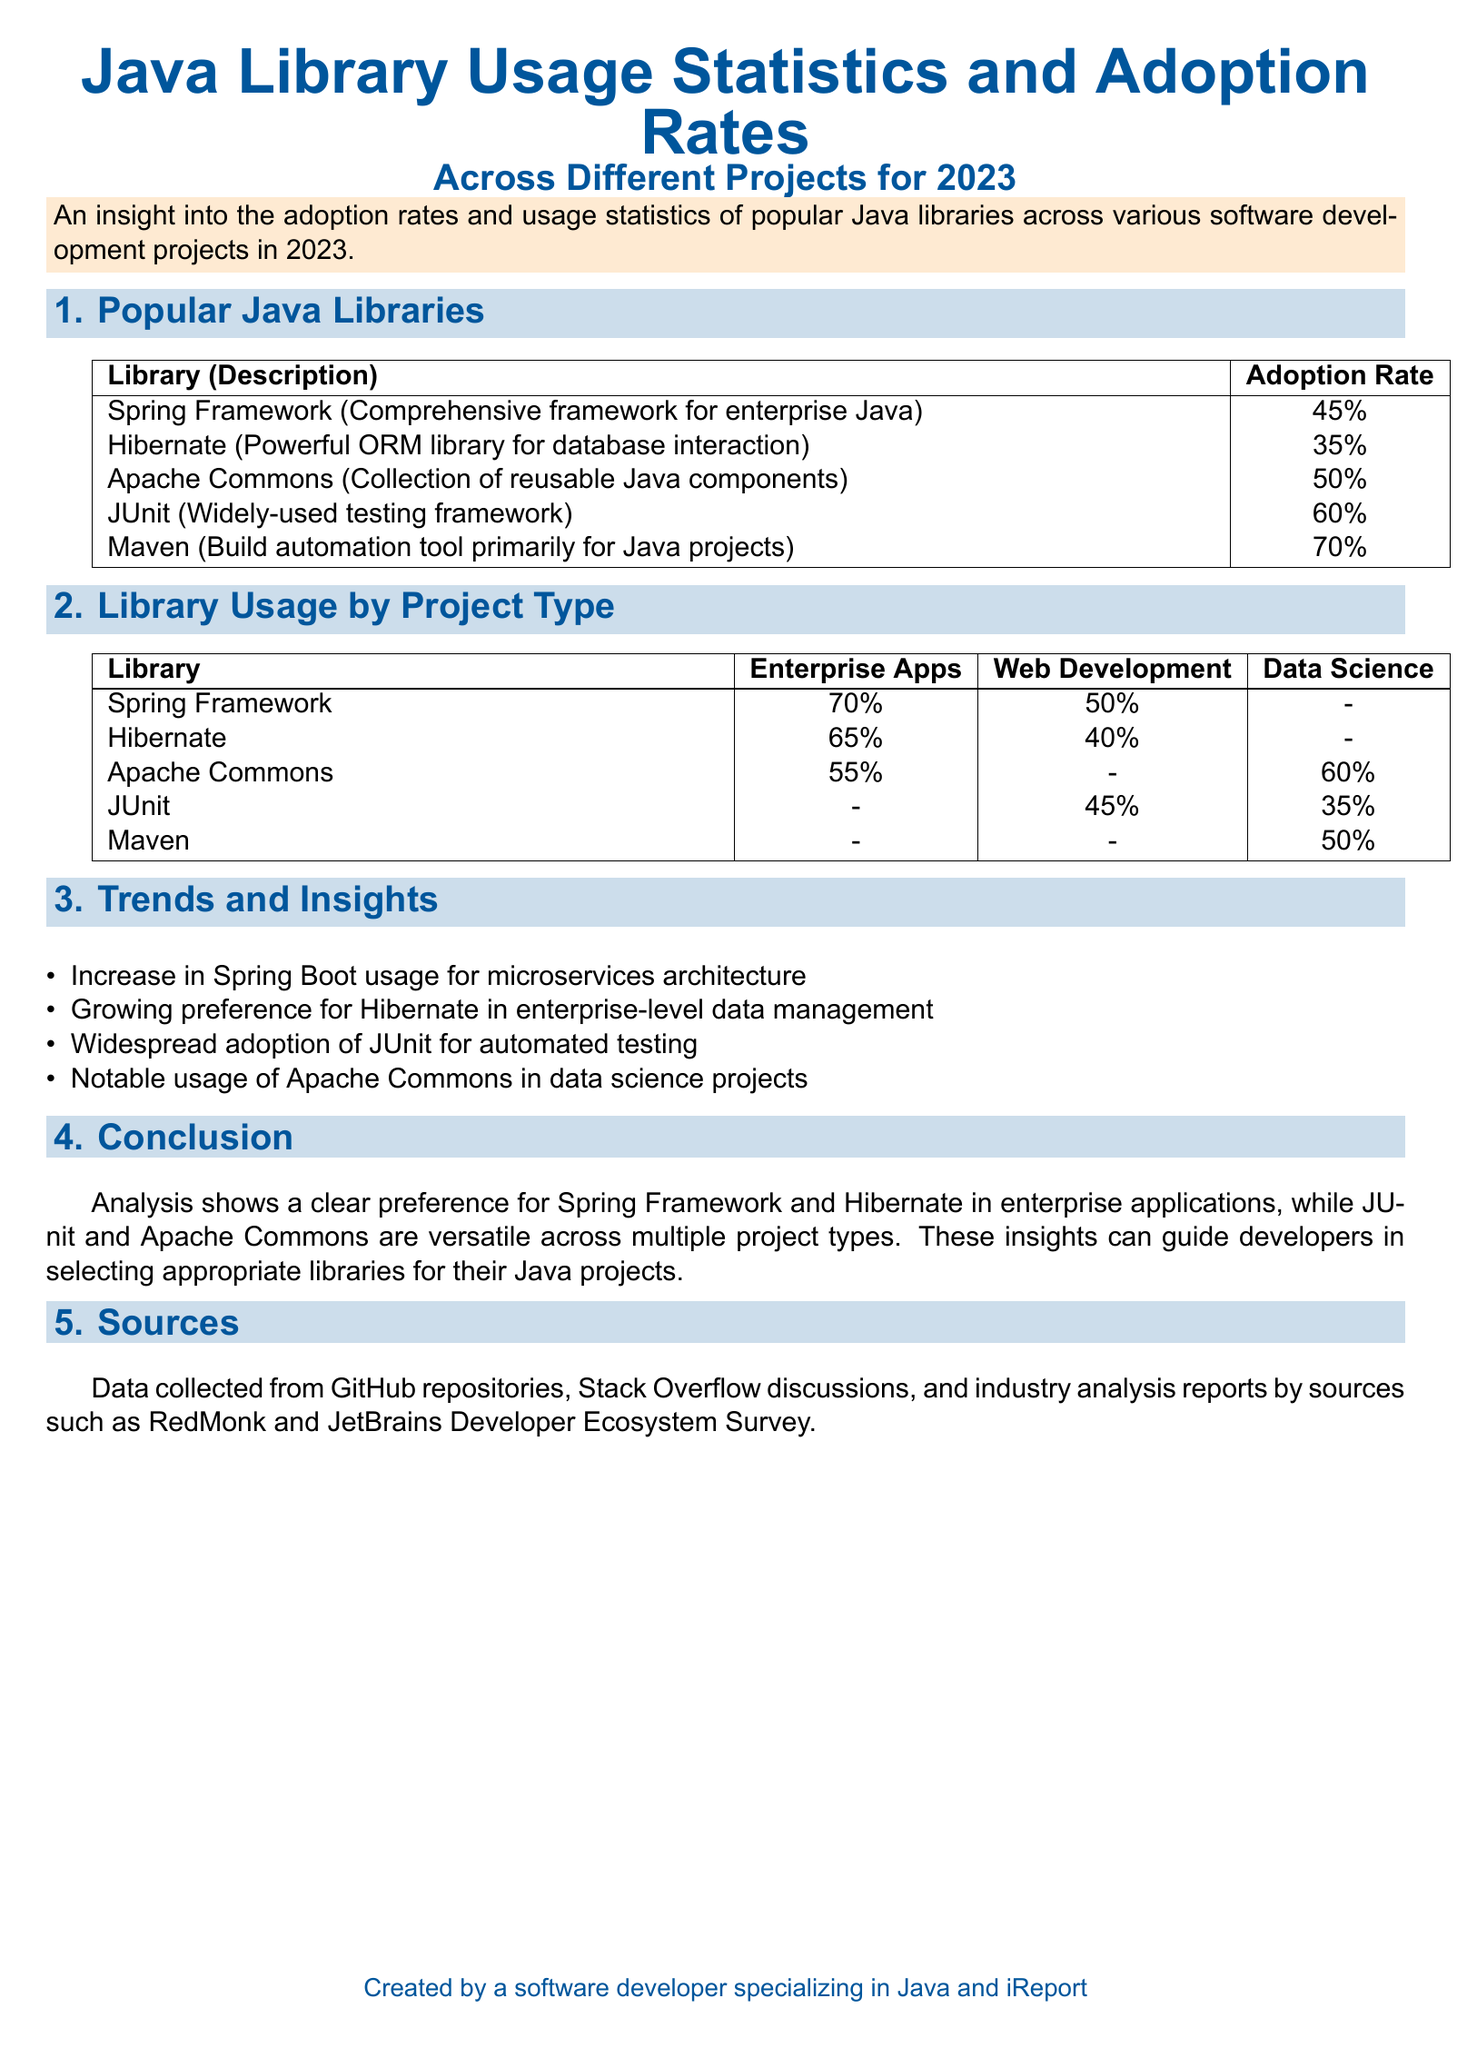What is the adoption rate of the Spring Framework? The adoption rate for Spring Framework is listed in the document, which is 45%.
Answer: 45% Which library has the highest adoption rate? The document lists the adoption rates of various Java libraries, identifying Maven as having the highest rate at 70%.
Answer: 70% What percentage of enterprise applications use Hibernate? The percentage usage of Hibernate in enterprise applications is specified as 65%.
Answer: 65% In which project type is JUnit used the least? The document indicates that JUnit is used the least in enterprise applications, showing no percentage provided for that category.
Answer: - What is a notable trend for Spring Boot usage? The document mentions an increase in Spring Boot usage, particularly for microservices architecture, as a notable trend.
Answer: Microservices architecture Which Java library shows notable usage in data science projects? The document highlights Apache Commons for its notable usage in data science projects.
Answer: Apache Commons What is the purpose of the document? The document provides insights into the adoption rates and usage statistics of Java libraries for 2023.
Answer: Adoption rates and usage statistics How is data collected for the analysis in the datasheet? The sources of data collection are specified as GitHub repositories, Stack Overflow discussions, and various industry reports.
Answer: GitHub, Stack Overflow, industry reports What percentage of web development projects use the Spring Framework? The document states that 50% of web development projects utilize the Spring Framework.
Answer: 50% 